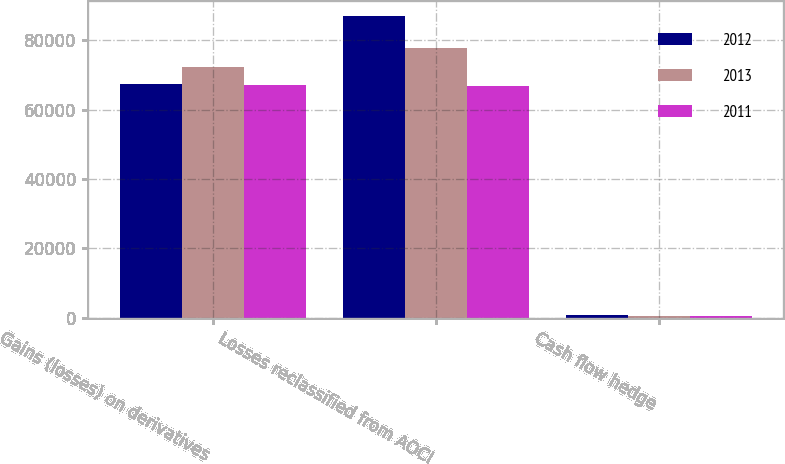Convert chart. <chart><loc_0><loc_0><loc_500><loc_500><stacked_bar_chart><ecel><fcel>Gains (losses) on derivatives<fcel>Losses reclassified from AOCI<fcel>Cash flow hedge<nl><fcel>2012<fcel>67337<fcel>86894<fcel>879<nl><fcel>2013<fcel>72119<fcel>77731<fcel>480<nl><fcel>2011<fcel>67092<fcel>66847<fcel>491<nl></chart> 